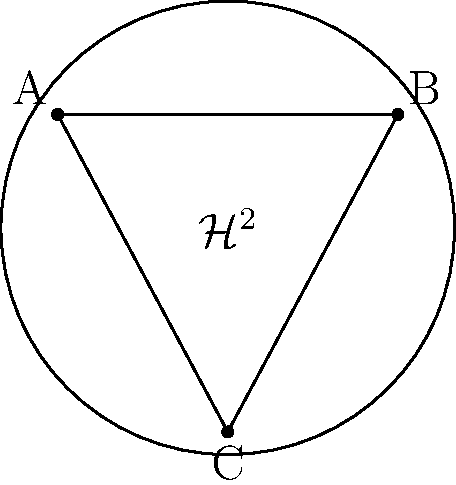In the hyperbolic plane model $\mathcal{H}^2$ shown above, triangle ABC is drawn. If the sum of the interior angles of this triangle is $150°$, what is the area of this triangle in terms of $R$, where $R$ is the radius of curvature of the hyperbolic plane? To solve this problem, we need to follow these steps:

1) In hyperbolic geometry, the area of a triangle is related to its angle deficit. The formula for the area $A$ of a hyperbolic triangle is:

   $$A = R^2(\pi - (\alpha + \beta + \gamma))$$

   where $R$ is the radius of curvature, and $\alpha$, $\beta$, and $\gamma$ are the interior angles of the triangle.

2) We're given that the sum of the interior angles is $150°$. Let's convert this to radians:

   $$150° \times \frac{\pi}{180°} = \frac{5\pi}{6}$$

3) Now, let's substitute this into our area formula:

   $$A = R^2(\pi - \frac{5\pi}{6})$$

4) Simplify:

   $$A = R^2(\frac{6\pi}{6} - \frac{5\pi}{6}) = R^2(\frac{\pi}{6})$$

5) Therefore, the area of the triangle is $\frac{\pi}{6}R^2$.

This result showcases how the curvature of space in a hyperbolic plane affects geometric properties, which is a crucial concept in material science, especially when dealing with non-Euclidean structures or materials.
Answer: $\frac{\pi}{6}R^2$ 